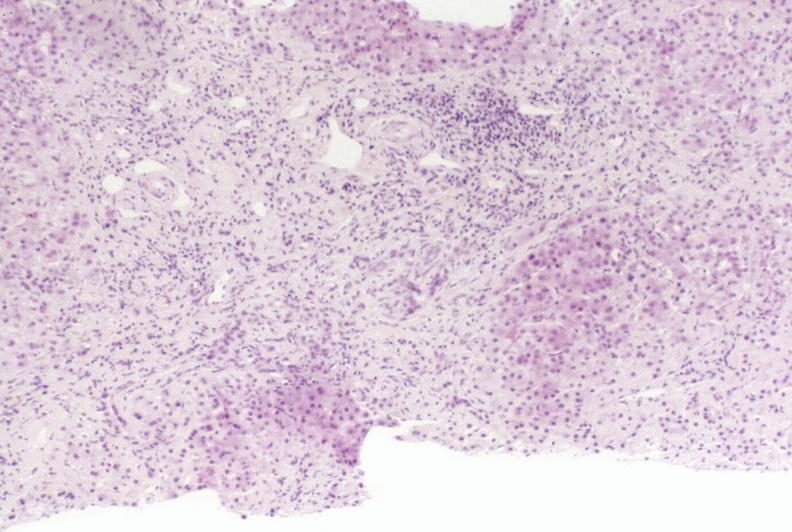s hepatobiliary present?
Answer the question using a single word or phrase. Yes 